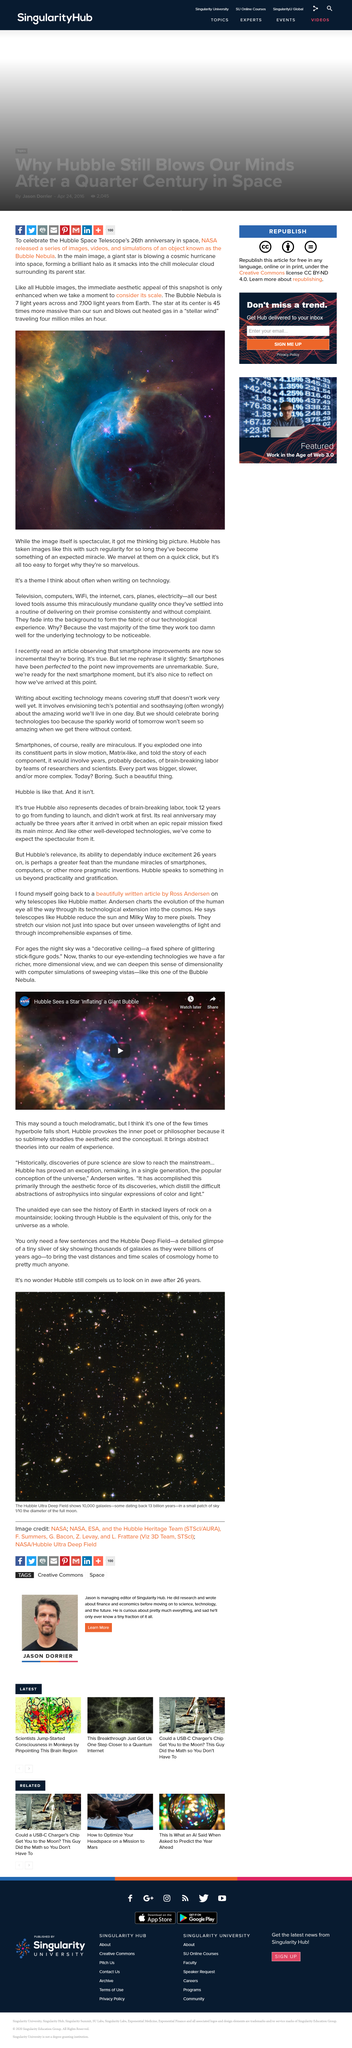Point out several critical features in this image. The star at the center of the Bubble Nebula is 45 times more massive than our sun. The unaided eye can see the history of Earth stacked in layers of rock on a mountainside. The image is a Hubble image and is confirmed. The Bubble Nebula is roughly 7 light-years in diameter, making it an impressive sight in the night sky. The Hubble Ultra Deep Field contains approximately 10,000 galaxies. 